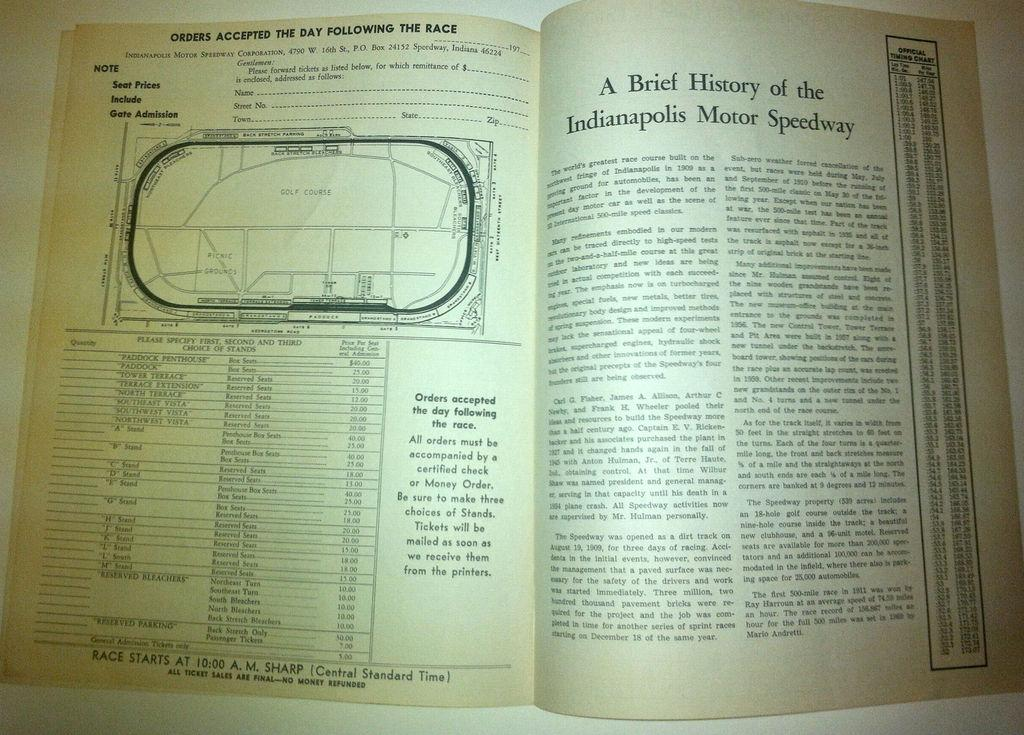<image>
Create a compact narrative representing the image presented. A book is open at a page discussing the Indianapolis Motor Speedway. 